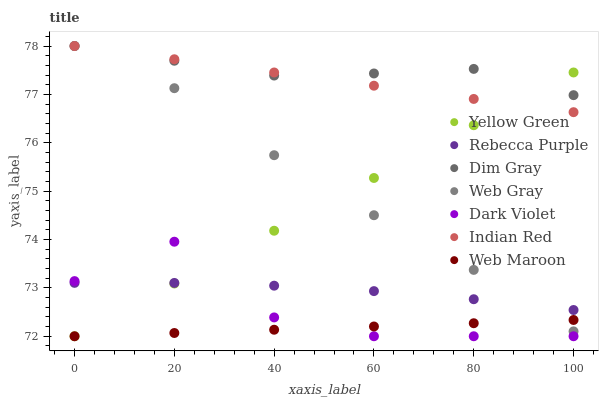Does Web Maroon have the minimum area under the curve?
Answer yes or no. Yes. Does Dim Gray have the maximum area under the curve?
Answer yes or no. Yes. Does Yellow Green have the minimum area under the curve?
Answer yes or no. No. Does Yellow Green have the maximum area under the curve?
Answer yes or no. No. Is Yellow Green the smoothest?
Answer yes or no. Yes. Is Dark Violet the roughest?
Answer yes or no. Yes. Is Web Maroon the smoothest?
Answer yes or no. No. Is Web Maroon the roughest?
Answer yes or no. No. Does Yellow Green have the lowest value?
Answer yes or no. Yes. Does Web Gray have the lowest value?
Answer yes or no. No. Does Indian Red have the highest value?
Answer yes or no. Yes. Does Yellow Green have the highest value?
Answer yes or no. No. Is Web Maroon less than Dim Gray?
Answer yes or no. Yes. Is Indian Red greater than Dark Violet?
Answer yes or no. Yes. Does Yellow Green intersect Rebecca Purple?
Answer yes or no. Yes. Is Yellow Green less than Rebecca Purple?
Answer yes or no. No. Is Yellow Green greater than Rebecca Purple?
Answer yes or no. No. Does Web Maroon intersect Dim Gray?
Answer yes or no. No. 